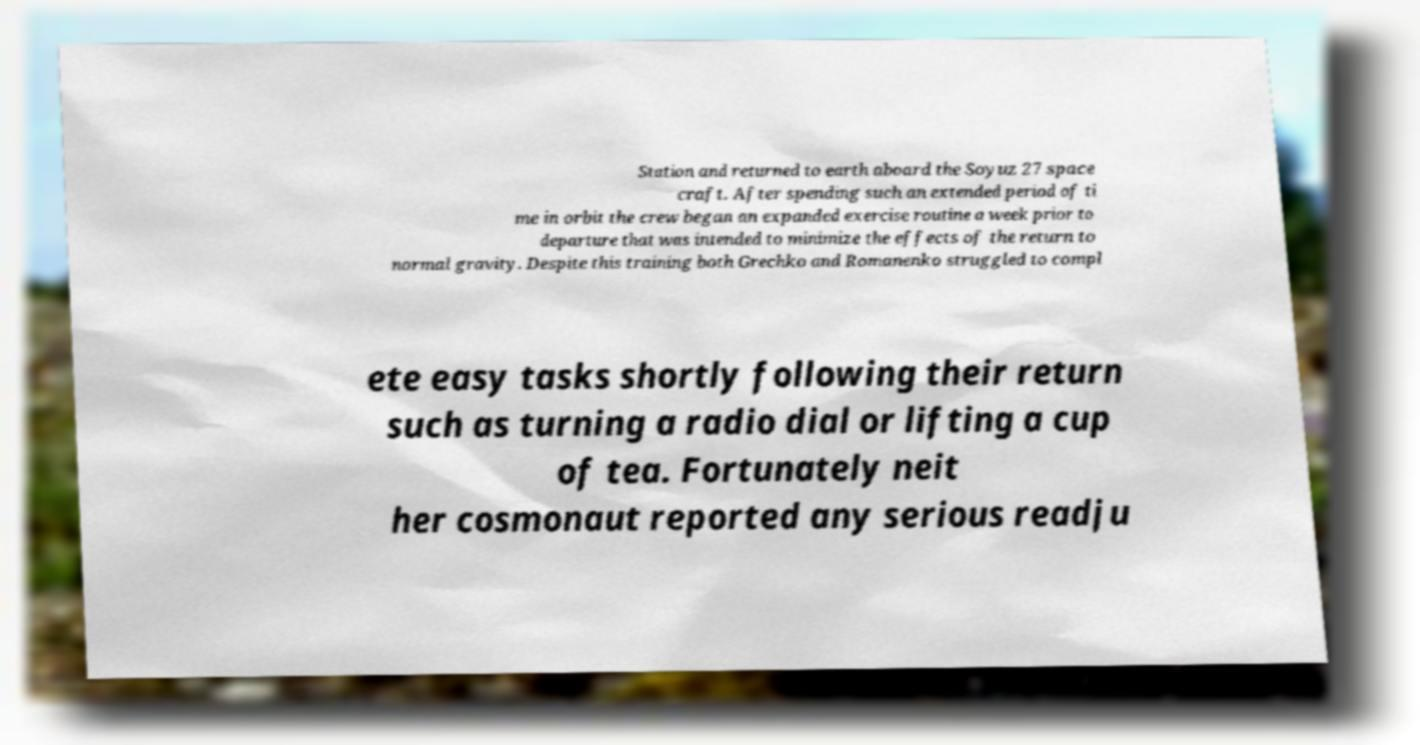What messages or text are displayed in this image? I need them in a readable, typed format. Station and returned to earth aboard the Soyuz 27 space craft. After spending such an extended period of ti me in orbit the crew began an expanded exercise routine a week prior to departure that was intended to minimize the effects of the return to normal gravity. Despite this training both Grechko and Romanenko struggled to compl ete easy tasks shortly following their return such as turning a radio dial or lifting a cup of tea. Fortunately neit her cosmonaut reported any serious readju 